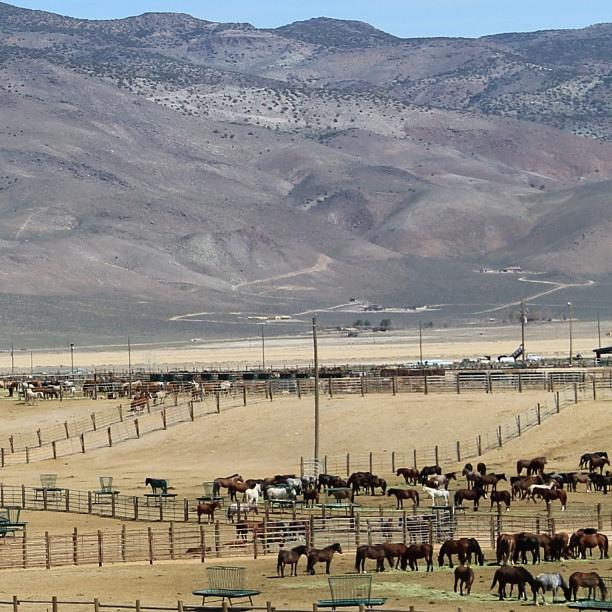Is this a marina?
Quick response, please. No. Is that mountain a volcano?
Be succinct. No. Is there more sky or land in this picture?
Answer briefly. Land. Is this a baseball field?
Give a very brief answer. No. Is this a major city?
Write a very short answer. No. Do the animals own this place?
Write a very short answer. No. 